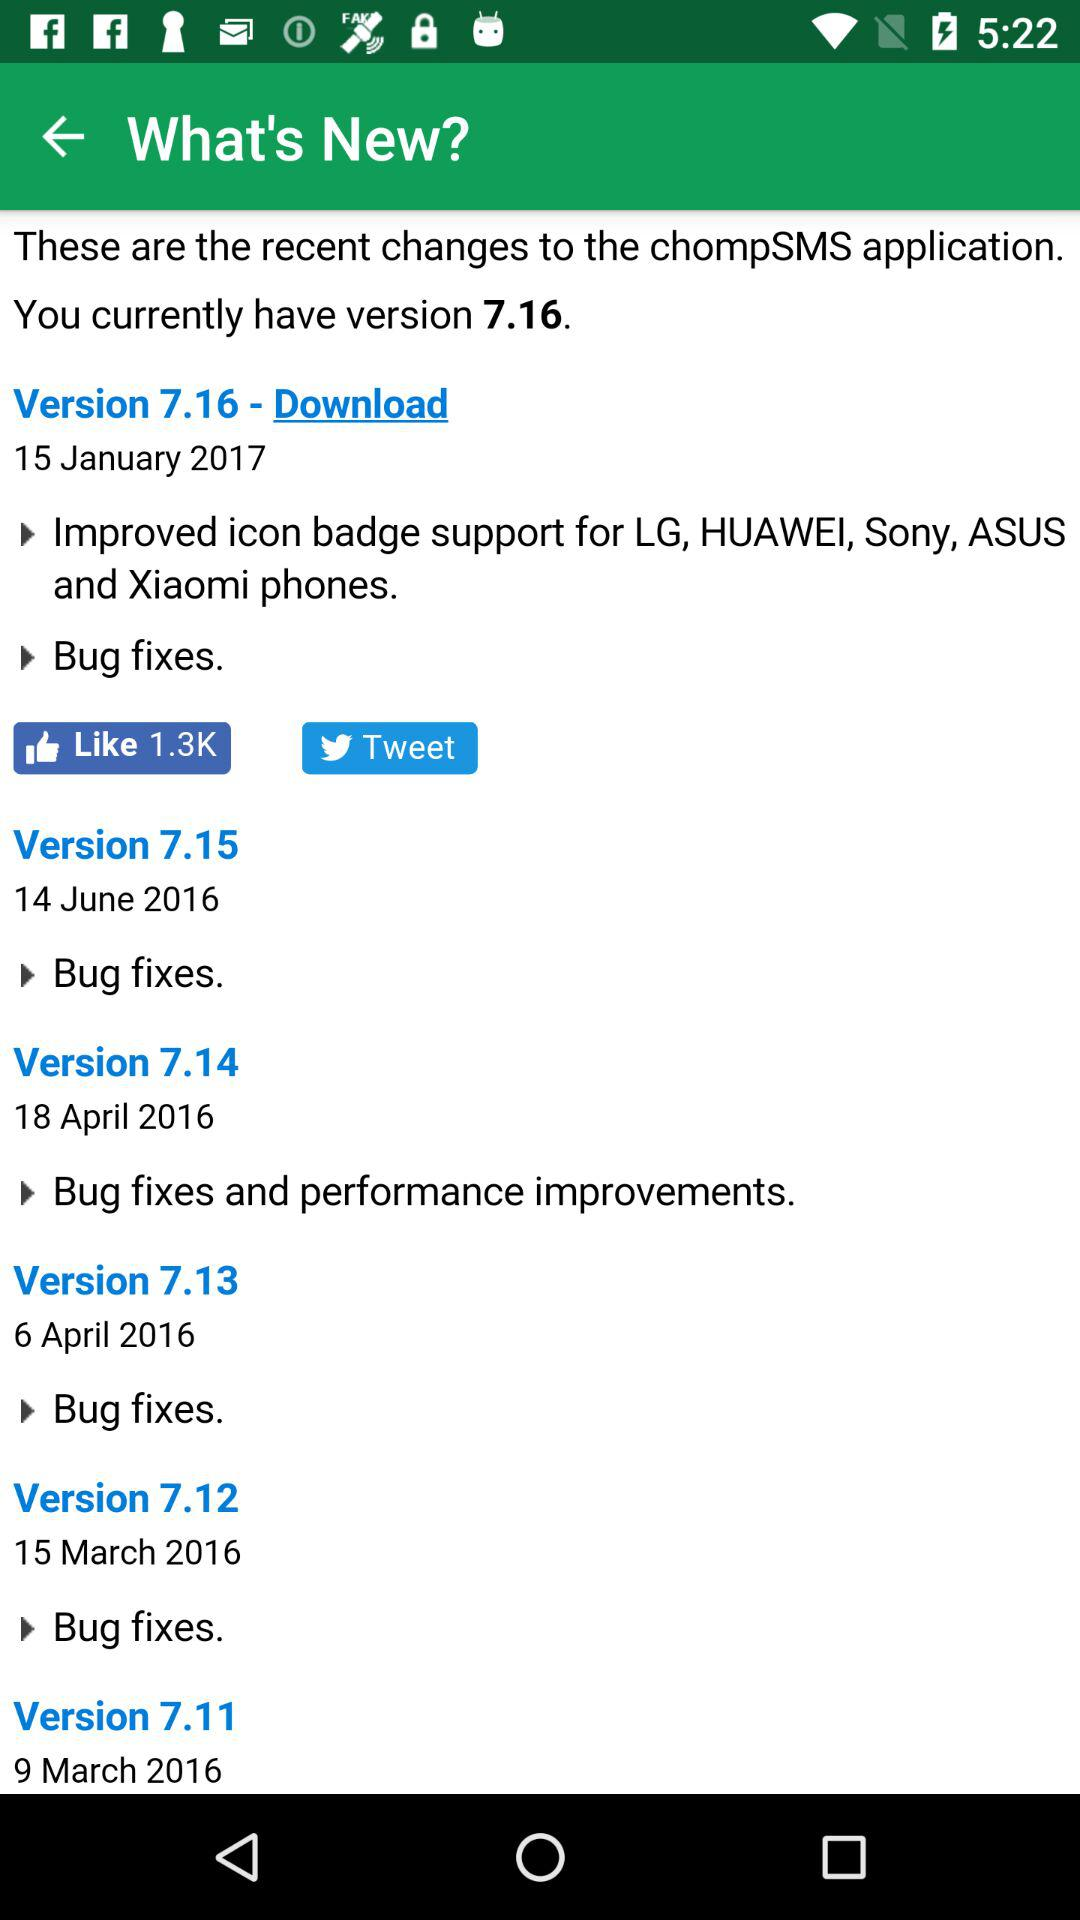What is the date given for version 7.16? The given date is January 15, 2017. 